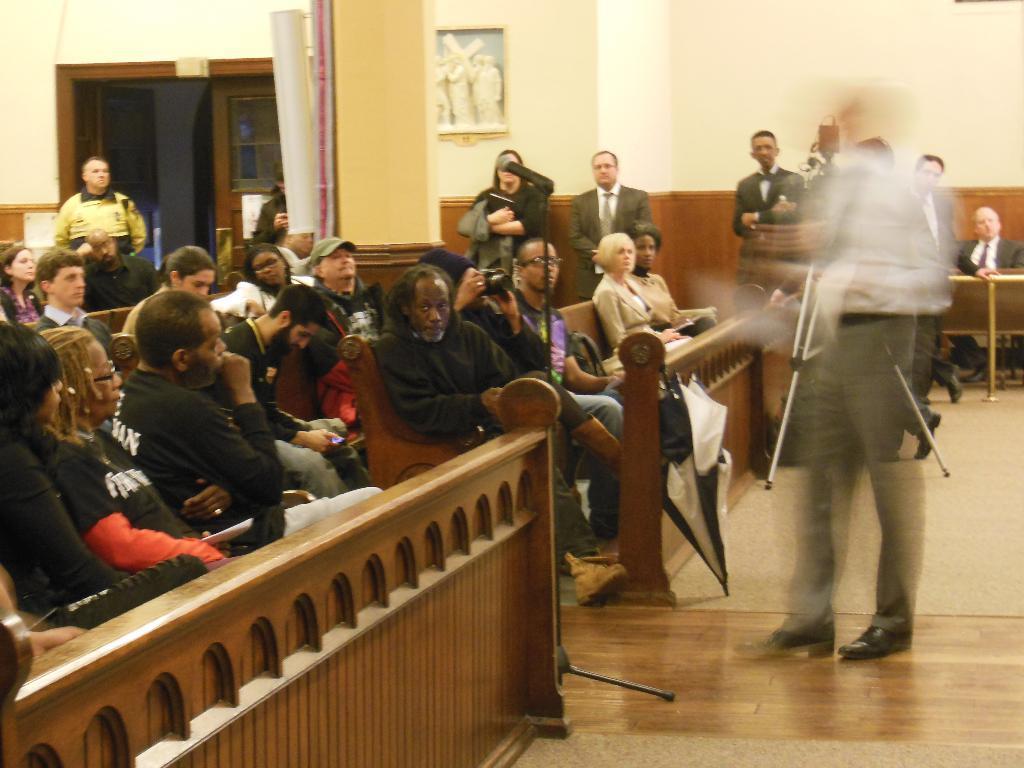Could you give a brief overview of what you see in this image? In this image, we can see some persons wearing clothes and sitting on benches. There are some other persons wearing clothes and standing in front of the wall. There is a door on the left side of the image. 